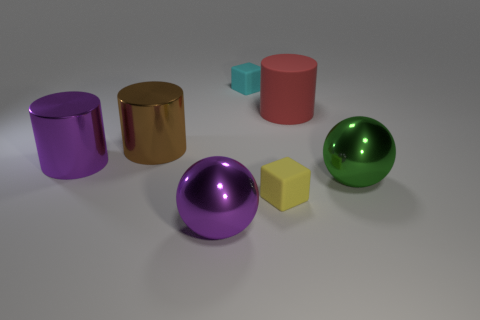There is another matte object that is the same shape as the tiny yellow object; what is its color? The object that shares the same cube shape as the tiny yellow object is the smaller pink cube. 